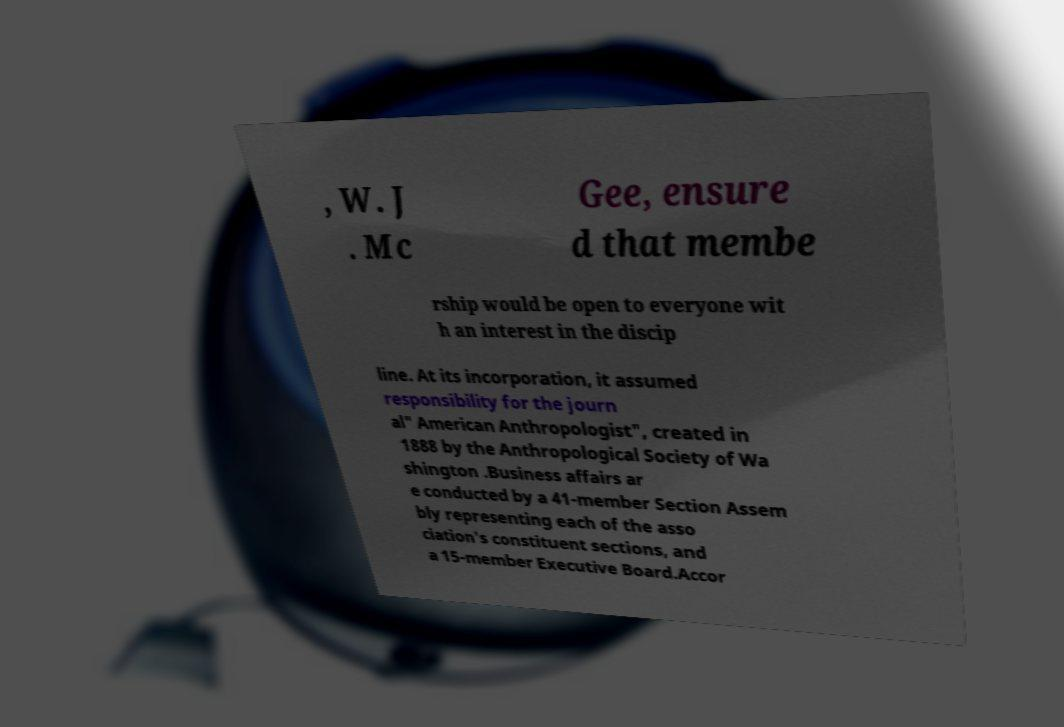What messages or text are displayed in this image? I need them in a readable, typed format. , W. J . Mc Gee, ensure d that membe rship would be open to everyone wit h an interest in the discip line. At its incorporation, it assumed responsibility for the journ al" American Anthropologist", created in 1888 by the Anthropological Society of Wa shington .Business affairs ar e conducted by a 41-member Section Assem bly representing each of the asso ciation's constituent sections, and a 15-member Executive Board.Accor 